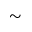<formula> <loc_0><loc_0><loc_500><loc_500>\sim</formula> 